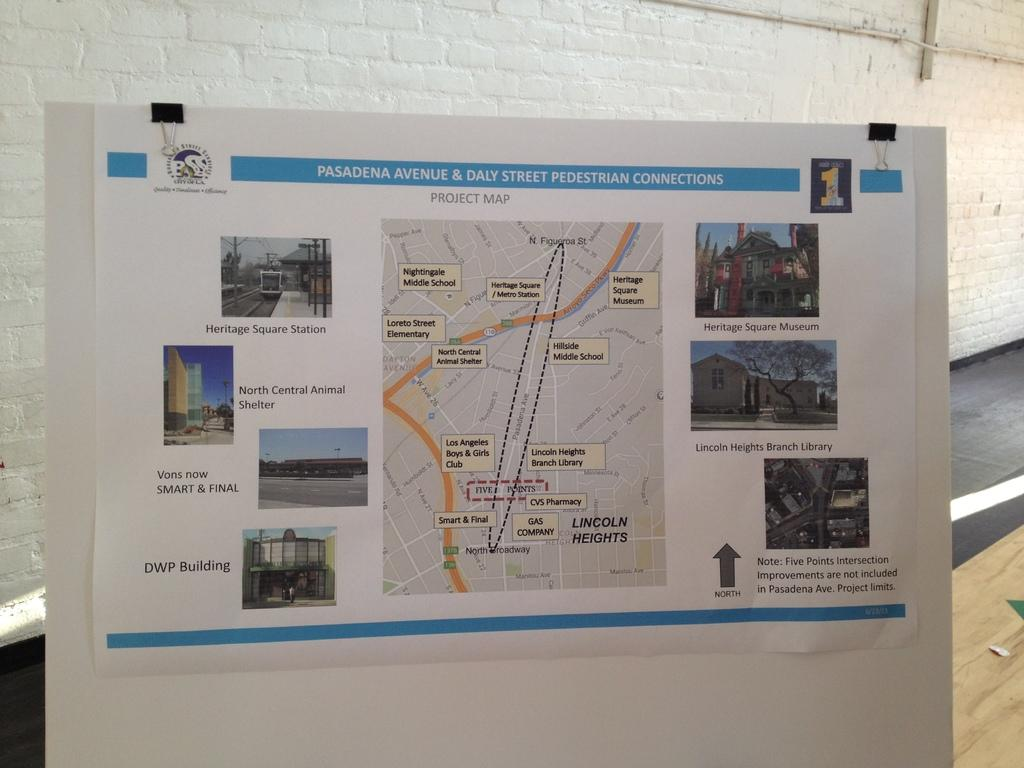Provide a one-sentence caption for the provided image. paper map of the city of pasadena ca. 